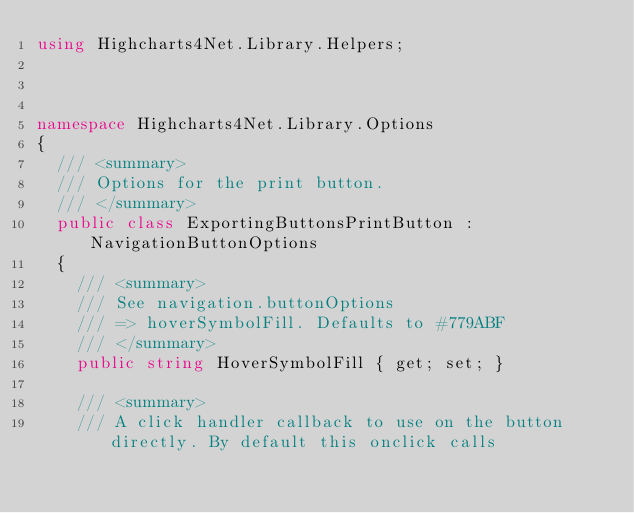Convert code to text. <code><loc_0><loc_0><loc_500><loc_500><_C#_>using Highcharts4Net.Library.Helpers;



namespace Highcharts4Net.Library.Options
{
	/// <summary>
	/// Options for the print button.
	/// </summary>
	public class ExportingButtonsPrintButton : NavigationButtonOptions
	{
		/// <summary>
		/// See navigation.buttonOptions
		/// => hoverSymbolFill. Defaults to #779ABF
		/// </summary>
		public string HoverSymbolFill { get; set; }

		/// <summary>
		/// A click handler callback to use on the button directly. By default this onclick calls</code> 